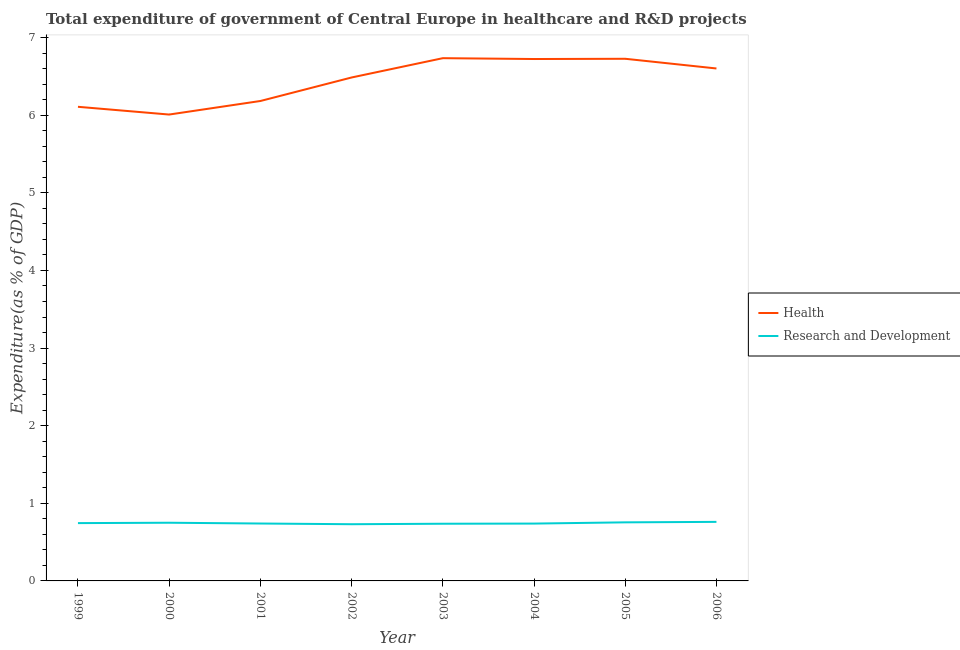What is the expenditure in healthcare in 1999?
Keep it short and to the point. 6.11. Across all years, what is the maximum expenditure in healthcare?
Offer a very short reply. 6.74. Across all years, what is the minimum expenditure in r&d?
Keep it short and to the point. 0.73. What is the total expenditure in healthcare in the graph?
Give a very brief answer. 51.58. What is the difference between the expenditure in healthcare in 1999 and that in 2002?
Provide a short and direct response. -0.38. What is the difference between the expenditure in healthcare in 2004 and the expenditure in r&d in 2001?
Offer a terse response. 5.98. What is the average expenditure in r&d per year?
Your response must be concise. 0.74. In the year 2001, what is the difference between the expenditure in r&d and expenditure in healthcare?
Your answer should be very brief. -5.44. In how many years, is the expenditure in healthcare greater than 4 %?
Provide a short and direct response. 8. What is the ratio of the expenditure in healthcare in 2004 to that in 2006?
Make the answer very short. 1.02. What is the difference between the highest and the second highest expenditure in healthcare?
Offer a terse response. 0.01. What is the difference between the highest and the lowest expenditure in healthcare?
Ensure brevity in your answer.  0.73. Does the expenditure in healthcare monotonically increase over the years?
Give a very brief answer. No. Is the expenditure in r&d strictly less than the expenditure in healthcare over the years?
Keep it short and to the point. Yes. Are the values on the major ticks of Y-axis written in scientific E-notation?
Your answer should be compact. No. Does the graph contain grids?
Ensure brevity in your answer.  No. How are the legend labels stacked?
Give a very brief answer. Vertical. What is the title of the graph?
Your answer should be very brief. Total expenditure of government of Central Europe in healthcare and R&D projects. Does "Drinking water services" appear as one of the legend labels in the graph?
Your answer should be compact. No. What is the label or title of the Y-axis?
Make the answer very short. Expenditure(as % of GDP). What is the Expenditure(as % of GDP) of Health in 1999?
Provide a succinct answer. 6.11. What is the Expenditure(as % of GDP) in Research and Development in 1999?
Provide a succinct answer. 0.74. What is the Expenditure(as % of GDP) of Health in 2000?
Your answer should be compact. 6.01. What is the Expenditure(as % of GDP) in Research and Development in 2000?
Give a very brief answer. 0.75. What is the Expenditure(as % of GDP) of Health in 2001?
Keep it short and to the point. 6.18. What is the Expenditure(as % of GDP) in Research and Development in 2001?
Offer a very short reply. 0.74. What is the Expenditure(as % of GDP) of Health in 2002?
Offer a terse response. 6.49. What is the Expenditure(as % of GDP) of Research and Development in 2002?
Give a very brief answer. 0.73. What is the Expenditure(as % of GDP) of Health in 2003?
Provide a short and direct response. 6.74. What is the Expenditure(as % of GDP) of Research and Development in 2003?
Ensure brevity in your answer.  0.74. What is the Expenditure(as % of GDP) of Health in 2004?
Provide a succinct answer. 6.72. What is the Expenditure(as % of GDP) in Research and Development in 2004?
Your answer should be compact. 0.74. What is the Expenditure(as % of GDP) of Health in 2005?
Your response must be concise. 6.73. What is the Expenditure(as % of GDP) in Research and Development in 2005?
Give a very brief answer. 0.75. What is the Expenditure(as % of GDP) of Health in 2006?
Keep it short and to the point. 6.6. What is the Expenditure(as % of GDP) of Research and Development in 2006?
Your response must be concise. 0.76. Across all years, what is the maximum Expenditure(as % of GDP) of Health?
Your response must be concise. 6.74. Across all years, what is the maximum Expenditure(as % of GDP) of Research and Development?
Make the answer very short. 0.76. Across all years, what is the minimum Expenditure(as % of GDP) in Health?
Your response must be concise. 6.01. Across all years, what is the minimum Expenditure(as % of GDP) in Research and Development?
Make the answer very short. 0.73. What is the total Expenditure(as % of GDP) in Health in the graph?
Keep it short and to the point. 51.58. What is the total Expenditure(as % of GDP) of Research and Development in the graph?
Give a very brief answer. 5.96. What is the difference between the Expenditure(as % of GDP) of Health in 1999 and that in 2000?
Offer a terse response. 0.1. What is the difference between the Expenditure(as % of GDP) in Research and Development in 1999 and that in 2000?
Offer a very short reply. -0. What is the difference between the Expenditure(as % of GDP) of Health in 1999 and that in 2001?
Offer a very short reply. -0.07. What is the difference between the Expenditure(as % of GDP) of Research and Development in 1999 and that in 2001?
Your answer should be very brief. 0.01. What is the difference between the Expenditure(as % of GDP) in Health in 1999 and that in 2002?
Offer a terse response. -0.38. What is the difference between the Expenditure(as % of GDP) of Research and Development in 1999 and that in 2002?
Offer a very short reply. 0.01. What is the difference between the Expenditure(as % of GDP) of Health in 1999 and that in 2003?
Your answer should be very brief. -0.63. What is the difference between the Expenditure(as % of GDP) in Research and Development in 1999 and that in 2003?
Offer a terse response. 0.01. What is the difference between the Expenditure(as % of GDP) of Health in 1999 and that in 2004?
Ensure brevity in your answer.  -0.62. What is the difference between the Expenditure(as % of GDP) in Research and Development in 1999 and that in 2004?
Offer a very short reply. 0.01. What is the difference between the Expenditure(as % of GDP) of Health in 1999 and that in 2005?
Give a very brief answer. -0.62. What is the difference between the Expenditure(as % of GDP) in Research and Development in 1999 and that in 2005?
Give a very brief answer. -0.01. What is the difference between the Expenditure(as % of GDP) in Health in 1999 and that in 2006?
Your response must be concise. -0.49. What is the difference between the Expenditure(as % of GDP) in Research and Development in 1999 and that in 2006?
Your answer should be very brief. -0.02. What is the difference between the Expenditure(as % of GDP) in Health in 2000 and that in 2001?
Your answer should be very brief. -0.17. What is the difference between the Expenditure(as % of GDP) of Health in 2000 and that in 2002?
Keep it short and to the point. -0.48. What is the difference between the Expenditure(as % of GDP) in Research and Development in 2000 and that in 2002?
Your answer should be very brief. 0.02. What is the difference between the Expenditure(as % of GDP) in Health in 2000 and that in 2003?
Offer a terse response. -0.73. What is the difference between the Expenditure(as % of GDP) of Research and Development in 2000 and that in 2003?
Ensure brevity in your answer.  0.01. What is the difference between the Expenditure(as % of GDP) in Health in 2000 and that in 2004?
Your answer should be compact. -0.72. What is the difference between the Expenditure(as % of GDP) in Research and Development in 2000 and that in 2004?
Your response must be concise. 0.01. What is the difference between the Expenditure(as % of GDP) in Health in 2000 and that in 2005?
Offer a terse response. -0.72. What is the difference between the Expenditure(as % of GDP) in Research and Development in 2000 and that in 2005?
Provide a succinct answer. -0.01. What is the difference between the Expenditure(as % of GDP) in Health in 2000 and that in 2006?
Provide a succinct answer. -0.59. What is the difference between the Expenditure(as % of GDP) of Research and Development in 2000 and that in 2006?
Your answer should be very brief. -0.01. What is the difference between the Expenditure(as % of GDP) of Health in 2001 and that in 2002?
Keep it short and to the point. -0.3. What is the difference between the Expenditure(as % of GDP) of Research and Development in 2001 and that in 2002?
Your answer should be compact. 0.01. What is the difference between the Expenditure(as % of GDP) of Health in 2001 and that in 2003?
Provide a succinct answer. -0.55. What is the difference between the Expenditure(as % of GDP) in Research and Development in 2001 and that in 2003?
Make the answer very short. 0. What is the difference between the Expenditure(as % of GDP) of Health in 2001 and that in 2004?
Keep it short and to the point. -0.54. What is the difference between the Expenditure(as % of GDP) of Research and Development in 2001 and that in 2004?
Make the answer very short. 0. What is the difference between the Expenditure(as % of GDP) of Health in 2001 and that in 2005?
Provide a short and direct response. -0.54. What is the difference between the Expenditure(as % of GDP) of Research and Development in 2001 and that in 2005?
Keep it short and to the point. -0.02. What is the difference between the Expenditure(as % of GDP) in Health in 2001 and that in 2006?
Make the answer very short. -0.42. What is the difference between the Expenditure(as % of GDP) of Research and Development in 2001 and that in 2006?
Offer a terse response. -0.02. What is the difference between the Expenditure(as % of GDP) in Health in 2002 and that in 2003?
Provide a succinct answer. -0.25. What is the difference between the Expenditure(as % of GDP) in Research and Development in 2002 and that in 2003?
Make the answer very short. -0.01. What is the difference between the Expenditure(as % of GDP) of Health in 2002 and that in 2004?
Make the answer very short. -0.24. What is the difference between the Expenditure(as % of GDP) in Research and Development in 2002 and that in 2004?
Offer a terse response. -0.01. What is the difference between the Expenditure(as % of GDP) of Health in 2002 and that in 2005?
Provide a short and direct response. -0.24. What is the difference between the Expenditure(as % of GDP) in Research and Development in 2002 and that in 2005?
Make the answer very short. -0.02. What is the difference between the Expenditure(as % of GDP) of Health in 2002 and that in 2006?
Provide a short and direct response. -0.12. What is the difference between the Expenditure(as % of GDP) of Research and Development in 2002 and that in 2006?
Ensure brevity in your answer.  -0.03. What is the difference between the Expenditure(as % of GDP) of Health in 2003 and that in 2004?
Your answer should be compact. 0.01. What is the difference between the Expenditure(as % of GDP) of Research and Development in 2003 and that in 2004?
Give a very brief answer. -0. What is the difference between the Expenditure(as % of GDP) in Health in 2003 and that in 2005?
Offer a terse response. 0.01. What is the difference between the Expenditure(as % of GDP) of Research and Development in 2003 and that in 2005?
Offer a terse response. -0.02. What is the difference between the Expenditure(as % of GDP) in Health in 2003 and that in 2006?
Your answer should be compact. 0.13. What is the difference between the Expenditure(as % of GDP) of Research and Development in 2003 and that in 2006?
Provide a short and direct response. -0.02. What is the difference between the Expenditure(as % of GDP) in Health in 2004 and that in 2005?
Make the answer very short. -0. What is the difference between the Expenditure(as % of GDP) in Research and Development in 2004 and that in 2005?
Provide a short and direct response. -0.02. What is the difference between the Expenditure(as % of GDP) in Health in 2004 and that in 2006?
Offer a very short reply. 0.12. What is the difference between the Expenditure(as % of GDP) in Research and Development in 2004 and that in 2006?
Provide a short and direct response. -0.02. What is the difference between the Expenditure(as % of GDP) in Health in 2005 and that in 2006?
Provide a succinct answer. 0.13. What is the difference between the Expenditure(as % of GDP) of Research and Development in 2005 and that in 2006?
Give a very brief answer. -0.01. What is the difference between the Expenditure(as % of GDP) of Health in 1999 and the Expenditure(as % of GDP) of Research and Development in 2000?
Your answer should be compact. 5.36. What is the difference between the Expenditure(as % of GDP) in Health in 1999 and the Expenditure(as % of GDP) in Research and Development in 2001?
Your answer should be compact. 5.37. What is the difference between the Expenditure(as % of GDP) of Health in 1999 and the Expenditure(as % of GDP) of Research and Development in 2002?
Your answer should be compact. 5.38. What is the difference between the Expenditure(as % of GDP) of Health in 1999 and the Expenditure(as % of GDP) of Research and Development in 2003?
Offer a terse response. 5.37. What is the difference between the Expenditure(as % of GDP) of Health in 1999 and the Expenditure(as % of GDP) of Research and Development in 2004?
Your answer should be very brief. 5.37. What is the difference between the Expenditure(as % of GDP) of Health in 1999 and the Expenditure(as % of GDP) of Research and Development in 2005?
Provide a short and direct response. 5.35. What is the difference between the Expenditure(as % of GDP) of Health in 1999 and the Expenditure(as % of GDP) of Research and Development in 2006?
Provide a short and direct response. 5.35. What is the difference between the Expenditure(as % of GDP) in Health in 2000 and the Expenditure(as % of GDP) in Research and Development in 2001?
Give a very brief answer. 5.27. What is the difference between the Expenditure(as % of GDP) of Health in 2000 and the Expenditure(as % of GDP) of Research and Development in 2002?
Make the answer very short. 5.28. What is the difference between the Expenditure(as % of GDP) in Health in 2000 and the Expenditure(as % of GDP) in Research and Development in 2003?
Ensure brevity in your answer.  5.27. What is the difference between the Expenditure(as % of GDP) in Health in 2000 and the Expenditure(as % of GDP) in Research and Development in 2004?
Provide a succinct answer. 5.27. What is the difference between the Expenditure(as % of GDP) of Health in 2000 and the Expenditure(as % of GDP) of Research and Development in 2005?
Your response must be concise. 5.25. What is the difference between the Expenditure(as % of GDP) of Health in 2000 and the Expenditure(as % of GDP) of Research and Development in 2006?
Provide a short and direct response. 5.25. What is the difference between the Expenditure(as % of GDP) of Health in 2001 and the Expenditure(as % of GDP) of Research and Development in 2002?
Offer a very short reply. 5.45. What is the difference between the Expenditure(as % of GDP) in Health in 2001 and the Expenditure(as % of GDP) in Research and Development in 2003?
Keep it short and to the point. 5.45. What is the difference between the Expenditure(as % of GDP) in Health in 2001 and the Expenditure(as % of GDP) in Research and Development in 2004?
Keep it short and to the point. 5.44. What is the difference between the Expenditure(as % of GDP) of Health in 2001 and the Expenditure(as % of GDP) of Research and Development in 2005?
Provide a short and direct response. 5.43. What is the difference between the Expenditure(as % of GDP) of Health in 2001 and the Expenditure(as % of GDP) of Research and Development in 2006?
Give a very brief answer. 5.42. What is the difference between the Expenditure(as % of GDP) of Health in 2002 and the Expenditure(as % of GDP) of Research and Development in 2003?
Your answer should be compact. 5.75. What is the difference between the Expenditure(as % of GDP) in Health in 2002 and the Expenditure(as % of GDP) in Research and Development in 2004?
Your answer should be very brief. 5.75. What is the difference between the Expenditure(as % of GDP) of Health in 2002 and the Expenditure(as % of GDP) of Research and Development in 2005?
Offer a very short reply. 5.73. What is the difference between the Expenditure(as % of GDP) of Health in 2002 and the Expenditure(as % of GDP) of Research and Development in 2006?
Offer a terse response. 5.73. What is the difference between the Expenditure(as % of GDP) in Health in 2003 and the Expenditure(as % of GDP) in Research and Development in 2004?
Give a very brief answer. 6. What is the difference between the Expenditure(as % of GDP) in Health in 2003 and the Expenditure(as % of GDP) in Research and Development in 2005?
Your answer should be very brief. 5.98. What is the difference between the Expenditure(as % of GDP) in Health in 2003 and the Expenditure(as % of GDP) in Research and Development in 2006?
Give a very brief answer. 5.97. What is the difference between the Expenditure(as % of GDP) of Health in 2004 and the Expenditure(as % of GDP) of Research and Development in 2005?
Ensure brevity in your answer.  5.97. What is the difference between the Expenditure(as % of GDP) in Health in 2004 and the Expenditure(as % of GDP) in Research and Development in 2006?
Give a very brief answer. 5.96. What is the difference between the Expenditure(as % of GDP) of Health in 2005 and the Expenditure(as % of GDP) of Research and Development in 2006?
Give a very brief answer. 5.97. What is the average Expenditure(as % of GDP) of Health per year?
Your answer should be compact. 6.45. What is the average Expenditure(as % of GDP) of Research and Development per year?
Your answer should be compact. 0.74. In the year 1999, what is the difference between the Expenditure(as % of GDP) in Health and Expenditure(as % of GDP) in Research and Development?
Your response must be concise. 5.36. In the year 2000, what is the difference between the Expenditure(as % of GDP) of Health and Expenditure(as % of GDP) of Research and Development?
Ensure brevity in your answer.  5.26. In the year 2001, what is the difference between the Expenditure(as % of GDP) of Health and Expenditure(as % of GDP) of Research and Development?
Ensure brevity in your answer.  5.44. In the year 2002, what is the difference between the Expenditure(as % of GDP) in Health and Expenditure(as % of GDP) in Research and Development?
Keep it short and to the point. 5.76. In the year 2003, what is the difference between the Expenditure(as % of GDP) of Health and Expenditure(as % of GDP) of Research and Development?
Provide a short and direct response. 6. In the year 2004, what is the difference between the Expenditure(as % of GDP) of Health and Expenditure(as % of GDP) of Research and Development?
Your answer should be very brief. 5.99. In the year 2005, what is the difference between the Expenditure(as % of GDP) of Health and Expenditure(as % of GDP) of Research and Development?
Give a very brief answer. 5.97. In the year 2006, what is the difference between the Expenditure(as % of GDP) in Health and Expenditure(as % of GDP) in Research and Development?
Your response must be concise. 5.84. What is the ratio of the Expenditure(as % of GDP) in Health in 1999 to that in 2000?
Give a very brief answer. 1.02. What is the ratio of the Expenditure(as % of GDP) of Research and Development in 1999 to that in 2000?
Your answer should be very brief. 0.99. What is the ratio of the Expenditure(as % of GDP) of Health in 1999 to that in 2001?
Provide a succinct answer. 0.99. What is the ratio of the Expenditure(as % of GDP) of Research and Development in 1999 to that in 2001?
Your answer should be very brief. 1.01. What is the ratio of the Expenditure(as % of GDP) of Health in 1999 to that in 2002?
Make the answer very short. 0.94. What is the ratio of the Expenditure(as % of GDP) in Research and Development in 1999 to that in 2002?
Keep it short and to the point. 1.02. What is the ratio of the Expenditure(as % of GDP) of Health in 1999 to that in 2003?
Keep it short and to the point. 0.91. What is the ratio of the Expenditure(as % of GDP) of Research and Development in 1999 to that in 2003?
Offer a very short reply. 1.01. What is the ratio of the Expenditure(as % of GDP) in Health in 1999 to that in 2004?
Make the answer very short. 0.91. What is the ratio of the Expenditure(as % of GDP) of Research and Development in 1999 to that in 2004?
Your response must be concise. 1.01. What is the ratio of the Expenditure(as % of GDP) in Health in 1999 to that in 2005?
Provide a short and direct response. 0.91. What is the ratio of the Expenditure(as % of GDP) in Health in 1999 to that in 2006?
Offer a terse response. 0.93. What is the ratio of the Expenditure(as % of GDP) of Research and Development in 1999 to that in 2006?
Give a very brief answer. 0.98. What is the ratio of the Expenditure(as % of GDP) of Health in 2000 to that in 2001?
Your answer should be compact. 0.97. What is the ratio of the Expenditure(as % of GDP) of Research and Development in 2000 to that in 2001?
Provide a short and direct response. 1.01. What is the ratio of the Expenditure(as % of GDP) of Health in 2000 to that in 2002?
Your answer should be very brief. 0.93. What is the ratio of the Expenditure(as % of GDP) of Research and Development in 2000 to that in 2002?
Provide a succinct answer. 1.03. What is the ratio of the Expenditure(as % of GDP) in Health in 2000 to that in 2003?
Provide a short and direct response. 0.89. What is the ratio of the Expenditure(as % of GDP) of Research and Development in 2000 to that in 2003?
Provide a short and direct response. 1.02. What is the ratio of the Expenditure(as % of GDP) of Health in 2000 to that in 2004?
Provide a short and direct response. 0.89. What is the ratio of the Expenditure(as % of GDP) in Research and Development in 2000 to that in 2004?
Provide a succinct answer. 1.01. What is the ratio of the Expenditure(as % of GDP) in Health in 2000 to that in 2005?
Your answer should be very brief. 0.89. What is the ratio of the Expenditure(as % of GDP) in Health in 2000 to that in 2006?
Keep it short and to the point. 0.91. What is the ratio of the Expenditure(as % of GDP) of Research and Development in 2000 to that in 2006?
Keep it short and to the point. 0.99. What is the ratio of the Expenditure(as % of GDP) in Health in 2001 to that in 2002?
Offer a very short reply. 0.95. What is the ratio of the Expenditure(as % of GDP) of Research and Development in 2001 to that in 2002?
Your response must be concise. 1.01. What is the ratio of the Expenditure(as % of GDP) of Health in 2001 to that in 2003?
Ensure brevity in your answer.  0.92. What is the ratio of the Expenditure(as % of GDP) of Research and Development in 2001 to that in 2003?
Your response must be concise. 1. What is the ratio of the Expenditure(as % of GDP) of Health in 2001 to that in 2004?
Your answer should be compact. 0.92. What is the ratio of the Expenditure(as % of GDP) of Research and Development in 2001 to that in 2004?
Make the answer very short. 1. What is the ratio of the Expenditure(as % of GDP) in Health in 2001 to that in 2005?
Make the answer very short. 0.92. What is the ratio of the Expenditure(as % of GDP) in Research and Development in 2001 to that in 2005?
Provide a short and direct response. 0.98. What is the ratio of the Expenditure(as % of GDP) of Health in 2001 to that in 2006?
Give a very brief answer. 0.94. What is the ratio of the Expenditure(as % of GDP) in Research and Development in 2001 to that in 2006?
Give a very brief answer. 0.97. What is the ratio of the Expenditure(as % of GDP) in Health in 2002 to that in 2003?
Make the answer very short. 0.96. What is the ratio of the Expenditure(as % of GDP) in Research and Development in 2002 to that in 2003?
Provide a short and direct response. 0.99. What is the ratio of the Expenditure(as % of GDP) of Health in 2002 to that in 2004?
Your answer should be compact. 0.96. What is the ratio of the Expenditure(as % of GDP) of Health in 2002 to that in 2005?
Ensure brevity in your answer.  0.96. What is the ratio of the Expenditure(as % of GDP) in Research and Development in 2002 to that in 2005?
Your answer should be very brief. 0.97. What is the ratio of the Expenditure(as % of GDP) of Health in 2002 to that in 2006?
Offer a terse response. 0.98. What is the ratio of the Expenditure(as % of GDP) in Research and Development in 2002 to that in 2006?
Offer a terse response. 0.96. What is the ratio of the Expenditure(as % of GDP) in Health in 2003 to that in 2004?
Your answer should be compact. 1. What is the ratio of the Expenditure(as % of GDP) in Research and Development in 2003 to that in 2004?
Make the answer very short. 1. What is the ratio of the Expenditure(as % of GDP) in Health in 2003 to that in 2005?
Provide a succinct answer. 1. What is the ratio of the Expenditure(as % of GDP) in Research and Development in 2003 to that in 2005?
Provide a short and direct response. 0.98. What is the ratio of the Expenditure(as % of GDP) of Health in 2003 to that in 2006?
Your answer should be very brief. 1.02. What is the ratio of the Expenditure(as % of GDP) of Research and Development in 2003 to that in 2006?
Make the answer very short. 0.97. What is the ratio of the Expenditure(as % of GDP) in Health in 2004 to that in 2005?
Keep it short and to the point. 1. What is the ratio of the Expenditure(as % of GDP) of Research and Development in 2004 to that in 2005?
Your answer should be compact. 0.98. What is the ratio of the Expenditure(as % of GDP) of Health in 2004 to that in 2006?
Provide a succinct answer. 1.02. What is the ratio of the Expenditure(as % of GDP) in Research and Development in 2004 to that in 2006?
Your answer should be very brief. 0.97. What is the ratio of the Expenditure(as % of GDP) of Health in 2005 to that in 2006?
Give a very brief answer. 1.02. What is the ratio of the Expenditure(as % of GDP) in Research and Development in 2005 to that in 2006?
Ensure brevity in your answer.  0.99. What is the difference between the highest and the second highest Expenditure(as % of GDP) of Health?
Make the answer very short. 0.01. What is the difference between the highest and the second highest Expenditure(as % of GDP) in Research and Development?
Your answer should be very brief. 0.01. What is the difference between the highest and the lowest Expenditure(as % of GDP) in Health?
Provide a succinct answer. 0.73. What is the difference between the highest and the lowest Expenditure(as % of GDP) in Research and Development?
Offer a terse response. 0.03. 